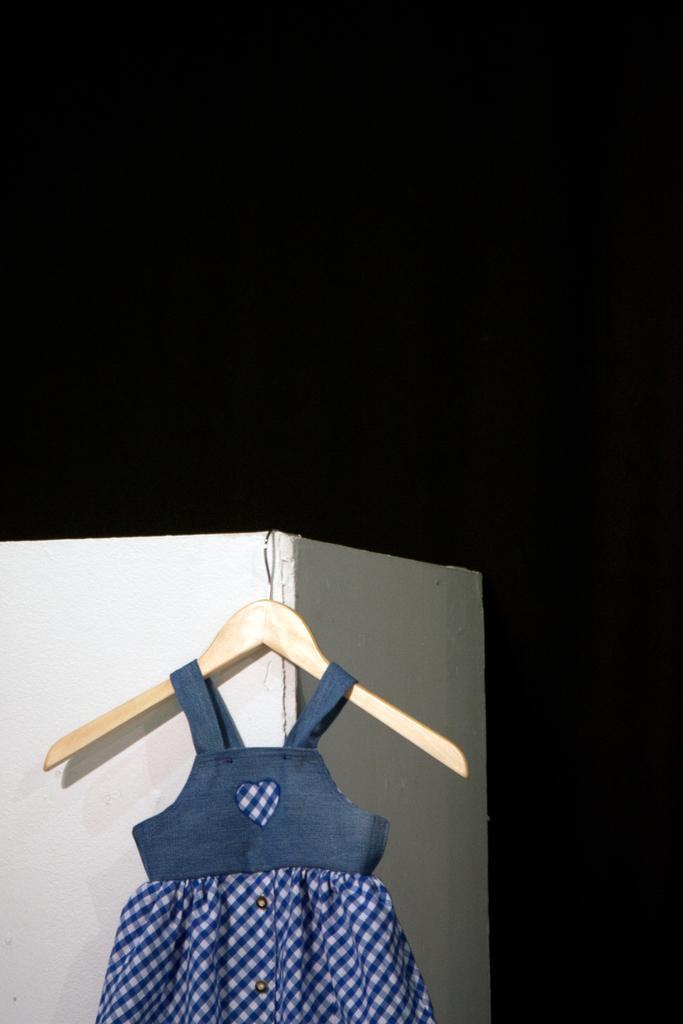How would you summarize this image in a sentence or two? In this image I can see a frock which is in blue color changed to a hanger, at back I can see a pillar in cream color and the background is in black color. 